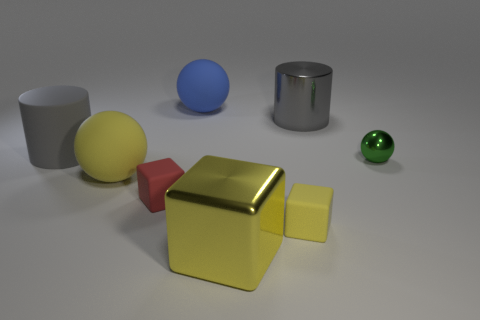Add 1 yellow cubes. How many objects exist? 9 Subtract all small cubes. How many cubes are left? 1 Subtract all blue balls. How many balls are left? 2 Subtract all cylinders. How many objects are left? 6 Subtract 1 cubes. How many cubes are left? 2 Subtract all purple balls. How many yellow cubes are left? 2 Add 7 tiny objects. How many tiny objects are left? 10 Add 2 big gray rubber things. How many big gray rubber things exist? 3 Subtract 0 brown balls. How many objects are left? 8 Subtract all blue balls. Subtract all brown cubes. How many balls are left? 2 